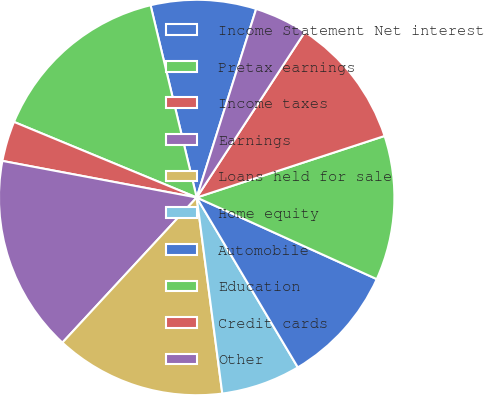Convert chart to OTSL. <chart><loc_0><loc_0><loc_500><loc_500><pie_chart><fcel>Income Statement Net interest<fcel>Pretax earnings<fcel>Income taxes<fcel>Earnings<fcel>Loans held for sale<fcel>Home equity<fcel>Automobile<fcel>Education<fcel>Credit cards<fcel>Other<nl><fcel>8.61%<fcel>15.01%<fcel>3.28%<fcel>16.08%<fcel>13.95%<fcel>6.48%<fcel>9.68%<fcel>11.81%<fcel>10.75%<fcel>4.35%<nl></chart> 